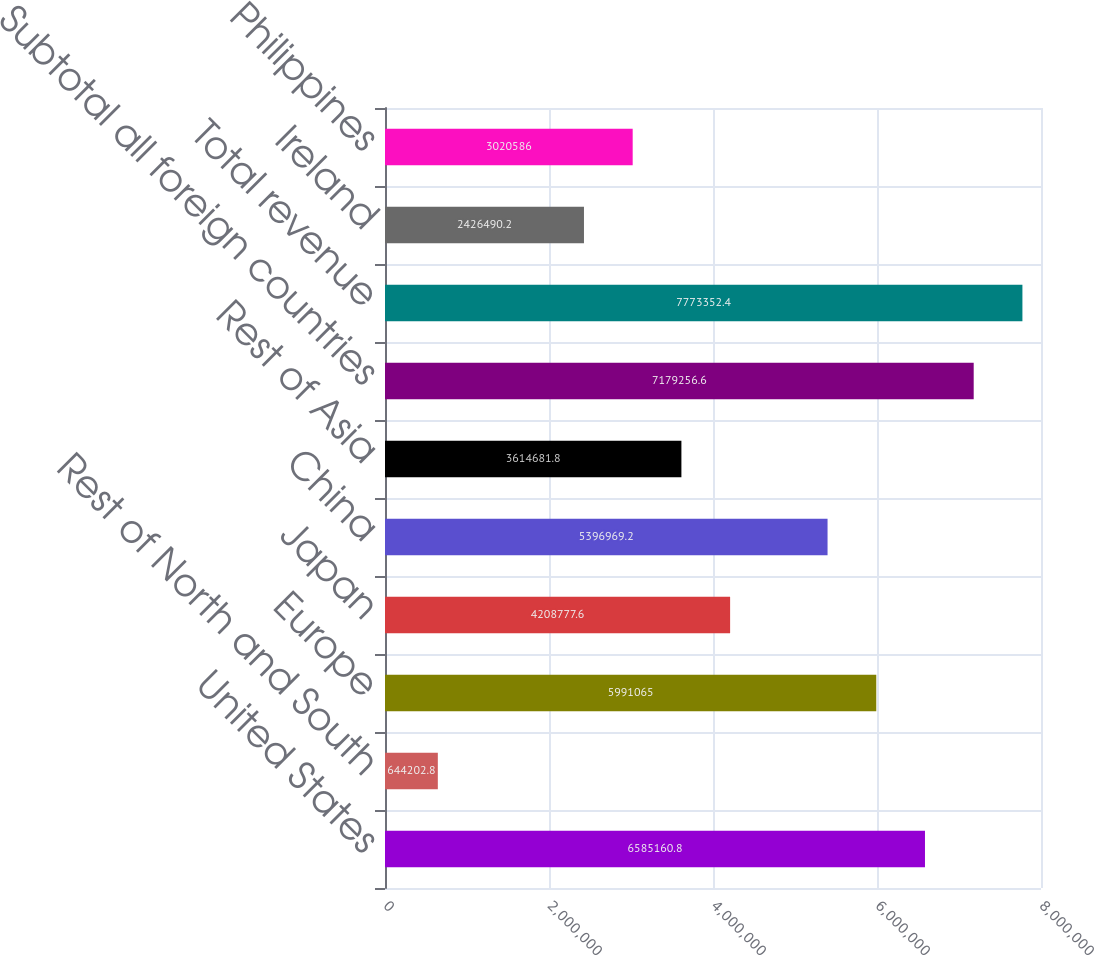<chart> <loc_0><loc_0><loc_500><loc_500><bar_chart><fcel>United States<fcel>Rest of North and South<fcel>Europe<fcel>Japan<fcel>China<fcel>Rest of Asia<fcel>Subtotal all foreign countries<fcel>Total revenue<fcel>Ireland<fcel>Philippines<nl><fcel>6.58516e+06<fcel>644203<fcel>5.99106e+06<fcel>4.20878e+06<fcel>5.39697e+06<fcel>3.61468e+06<fcel>7.17926e+06<fcel>7.77335e+06<fcel>2.42649e+06<fcel>3.02059e+06<nl></chart> 